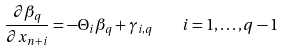Convert formula to latex. <formula><loc_0><loc_0><loc_500><loc_500>\frac { \partial \beta _ { q } } { \partial x _ { n + i } } = - \Theta _ { i } \beta _ { q } + \gamma _ { i , q } \quad i = 1 , \dots , q - 1</formula> 